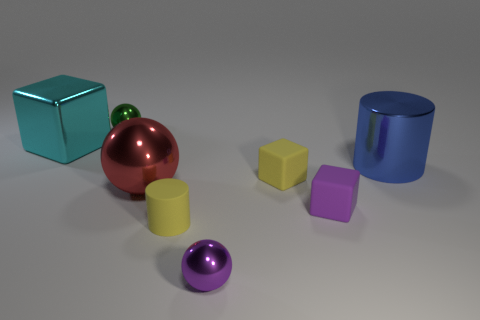What might the arrangement of these objects represent or symbolize? The arrangement of the objects doesn't seem to follow any particular pattern. However, one could interpret this as a study in geometry and color theory, showcasing how different shapes and colors can relate to each other in a space. It may also represent diversity in harmony, with each object standing out yet contributing to the overall balance of the scene. 